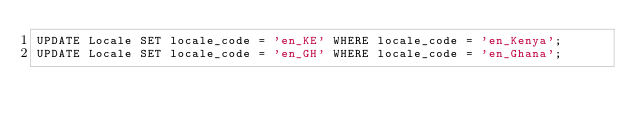<code> <loc_0><loc_0><loc_500><loc_500><_SQL_>UPDATE Locale SET locale_code = 'en_KE' WHERE locale_code = 'en_Kenya';
UPDATE Locale SET locale_code = 'en_GH' WHERE locale_code = 'en_Ghana';
</code> 